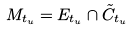<formula> <loc_0><loc_0><loc_500><loc_500>M _ { t _ { u } } = E _ { t _ { u } } \cap \tilde { C } _ { t _ { u } }</formula> 